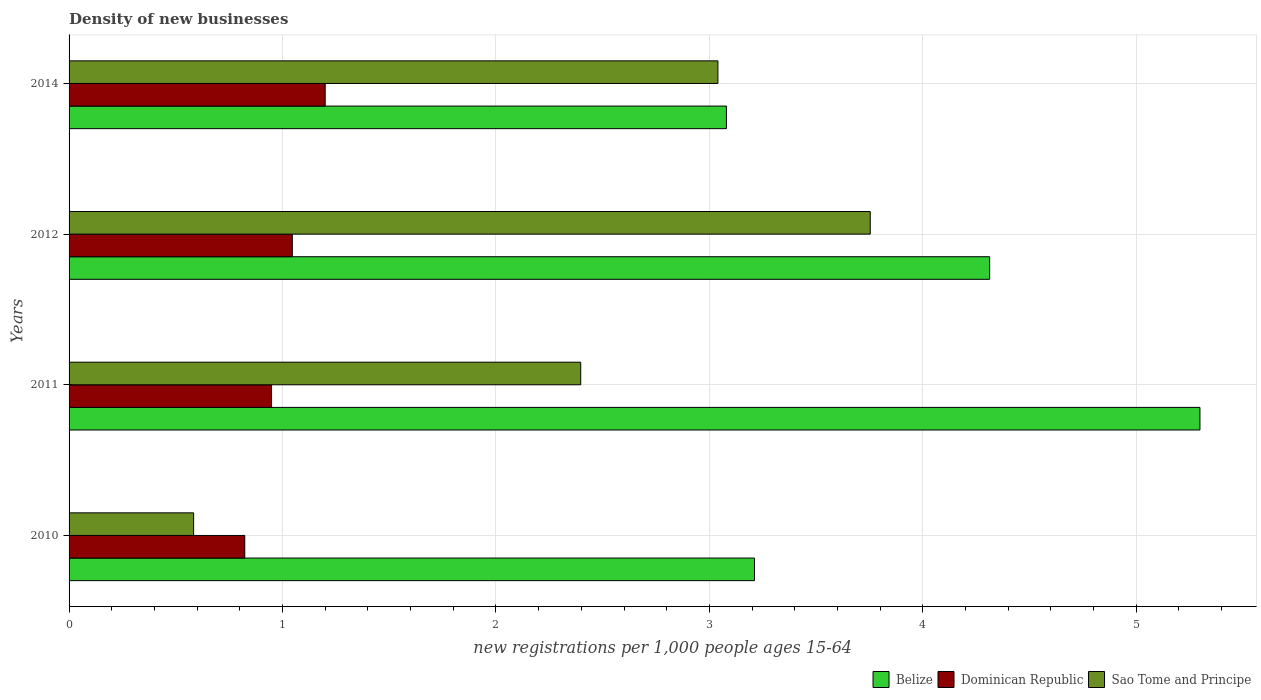Are the number of bars per tick equal to the number of legend labels?
Offer a very short reply. Yes. Are the number of bars on each tick of the Y-axis equal?
Your answer should be compact. Yes. How many bars are there on the 3rd tick from the top?
Offer a very short reply. 3. How many bars are there on the 1st tick from the bottom?
Ensure brevity in your answer.  3. What is the label of the 2nd group of bars from the top?
Ensure brevity in your answer.  2012. What is the number of new registrations in Belize in 2012?
Offer a very short reply. 4.31. Across all years, what is the maximum number of new registrations in Dominican Republic?
Keep it short and to the point. 1.2. Across all years, what is the minimum number of new registrations in Sao Tome and Principe?
Your response must be concise. 0.58. What is the total number of new registrations in Dominican Republic in the graph?
Your response must be concise. 4.02. What is the difference between the number of new registrations in Dominican Republic in 2010 and that in 2011?
Offer a very short reply. -0.13. What is the difference between the number of new registrations in Belize in 2011 and the number of new registrations in Dominican Republic in 2012?
Make the answer very short. 4.25. What is the average number of new registrations in Belize per year?
Provide a short and direct response. 3.98. In the year 2010, what is the difference between the number of new registrations in Sao Tome and Principe and number of new registrations in Dominican Republic?
Ensure brevity in your answer.  -0.24. What is the ratio of the number of new registrations in Belize in 2011 to that in 2014?
Provide a succinct answer. 1.72. What is the difference between the highest and the second highest number of new registrations in Sao Tome and Principe?
Your answer should be very brief. 0.71. What is the difference between the highest and the lowest number of new registrations in Dominican Republic?
Your answer should be very brief. 0.38. In how many years, is the number of new registrations in Sao Tome and Principe greater than the average number of new registrations in Sao Tome and Principe taken over all years?
Offer a very short reply. 2. Is the sum of the number of new registrations in Sao Tome and Principe in 2010 and 2014 greater than the maximum number of new registrations in Dominican Republic across all years?
Your answer should be very brief. Yes. What does the 1st bar from the top in 2012 represents?
Give a very brief answer. Sao Tome and Principe. What does the 3rd bar from the bottom in 2010 represents?
Provide a succinct answer. Sao Tome and Principe. How many bars are there?
Offer a terse response. 12. Are the values on the major ticks of X-axis written in scientific E-notation?
Your answer should be very brief. No. Does the graph contain any zero values?
Offer a very short reply. No. Does the graph contain grids?
Give a very brief answer. Yes. How many legend labels are there?
Provide a succinct answer. 3. How are the legend labels stacked?
Provide a short and direct response. Horizontal. What is the title of the graph?
Make the answer very short. Density of new businesses. What is the label or title of the X-axis?
Give a very brief answer. New registrations per 1,0 people ages 15-64. What is the label or title of the Y-axis?
Make the answer very short. Years. What is the new registrations per 1,000 people ages 15-64 of Belize in 2010?
Your answer should be very brief. 3.21. What is the new registrations per 1,000 people ages 15-64 of Dominican Republic in 2010?
Your answer should be compact. 0.82. What is the new registrations per 1,000 people ages 15-64 in Sao Tome and Principe in 2010?
Ensure brevity in your answer.  0.58. What is the new registrations per 1,000 people ages 15-64 of Belize in 2011?
Provide a succinct answer. 5.3. What is the new registrations per 1,000 people ages 15-64 in Dominican Republic in 2011?
Keep it short and to the point. 0.95. What is the new registrations per 1,000 people ages 15-64 in Sao Tome and Principe in 2011?
Keep it short and to the point. 2.4. What is the new registrations per 1,000 people ages 15-64 of Belize in 2012?
Provide a short and direct response. 4.31. What is the new registrations per 1,000 people ages 15-64 of Dominican Republic in 2012?
Make the answer very short. 1.05. What is the new registrations per 1,000 people ages 15-64 of Sao Tome and Principe in 2012?
Keep it short and to the point. 3.75. What is the new registrations per 1,000 people ages 15-64 of Belize in 2014?
Keep it short and to the point. 3.08. What is the new registrations per 1,000 people ages 15-64 of Sao Tome and Principe in 2014?
Provide a succinct answer. 3.04. Across all years, what is the maximum new registrations per 1,000 people ages 15-64 of Belize?
Keep it short and to the point. 5.3. Across all years, what is the maximum new registrations per 1,000 people ages 15-64 in Dominican Republic?
Provide a short and direct response. 1.2. Across all years, what is the maximum new registrations per 1,000 people ages 15-64 in Sao Tome and Principe?
Your response must be concise. 3.75. Across all years, what is the minimum new registrations per 1,000 people ages 15-64 in Belize?
Your answer should be compact. 3.08. Across all years, what is the minimum new registrations per 1,000 people ages 15-64 of Dominican Republic?
Your answer should be compact. 0.82. Across all years, what is the minimum new registrations per 1,000 people ages 15-64 of Sao Tome and Principe?
Make the answer very short. 0.58. What is the total new registrations per 1,000 people ages 15-64 of Belize in the graph?
Your answer should be compact. 15.9. What is the total new registrations per 1,000 people ages 15-64 of Dominican Republic in the graph?
Give a very brief answer. 4.02. What is the total new registrations per 1,000 people ages 15-64 of Sao Tome and Principe in the graph?
Offer a very short reply. 9.77. What is the difference between the new registrations per 1,000 people ages 15-64 in Belize in 2010 and that in 2011?
Your answer should be very brief. -2.09. What is the difference between the new registrations per 1,000 people ages 15-64 of Dominican Republic in 2010 and that in 2011?
Offer a terse response. -0.13. What is the difference between the new registrations per 1,000 people ages 15-64 in Sao Tome and Principe in 2010 and that in 2011?
Provide a succinct answer. -1.81. What is the difference between the new registrations per 1,000 people ages 15-64 in Belize in 2010 and that in 2012?
Provide a succinct answer. -1.1. What is the difference between the new registrations per 1,000 people ages 15-64 of Dominican Republic in 2010 and that in 2012?
Give a very brief answer. -0.22. What is the difference between the new registrations per 1,000 people ages 15-64 of Sao Tome and Principe in 2010 and that in 2012?
Ensure brevity in your answer.  -3.17. What is the difference between the new registrations per 1,000 people ages 15-64 of Belize in 2010 and that in 2014?
Offer a very short reply. 0.13. What is the difference between the new registrations per 1,000 people ages 15-64 of Dominican Republic in 2010 and that in 2014?
Keep it short and to the point. -0.38. What is the difference between the new registrations per 1,000 people ages 15-64 in Sao Tome and Principe in 2010 and that in 2014?
Your response must be concise. -2.46. What is the difference between the new registrations per 1,000 people ages 15-64 of Dominican Republic in 2011 and that in 2012?
Your response must be concise. -0.1. What is the difference between the new registrations per 1,000 people ages 15-64 of Sao Tome and Principe in 2011 and that in 2012?
Offer a terse response. -1.36. What is the difference between the new registrations per 1,000 people ages 15-64 of Belize in 2011 and that in 2014?
Offer a terse response. 2.22. What is the difference between the new registrations per 1,000 people ages 15-64 of Dominican Republic in 2011 and that in 2014?
Give a very brief answer. -0.25. What is the difference between the new registrations per 1,000 people ages 15-64 in Sao Tome and Principe in 2011 and that in 2014?
Provide a short and direct response. -0.64. What is the difference between the new registrations per 1,000 people ages 15-64 in Belize in 2012 and that in 2014?
Offer a very short reply. 1.23. What is the difference between the new registrations per 1,000 people ages 15-64 in Dominican Republic in 2012 and that in 2014?
Provide a succinct answer. -0.15. What is the difference between the new registrations per 1,000 people ages 15-64 in Sao Tome and Principe in 2012 and that in 2014?
Offer a very short reply. 0.71. What is the difference between the new registrations per 1,000 people ages 15-64 in Belize in 2010 and the new registrations per 1,000 people ages 15-64 in Dominican Republic in 2011?
Provide a short and direct response. 2.26. What is the difference between the new registrations per 1,000 people ages 15-64 of Belize in 2010 and the new registrations per 1,000 people ages 15-64 of Sao Tome and Principe in 2011?
Provide a short and direct response. 0.81. What is the difference between the new registrations per 1,000 people ages 15-64 in Dominican Republic in 2010 and the new registrations per 1,000 people ages 15-64 in Sao Tome and Principe in 2011?
Offer a terse response. -1.57. What is the difference between the new registrations per 1,000 people ages 15-64 of Belize in 2010 and the new registrations per 1,000 people ages 15-64 of Dominican Republic in 2012?
Your answer should be very brief. 2.17. What is the difference between the new registrations per 1,000 people ages 15-64 in Belize in 2010 and the new registrations per 1,000 people ages 15-64 in Sao Tome and Principe in 2012?
Your answer should be compact. -0.54. What is the difference between the new registrations per 1,000 people ages 15-64 of Dominican Republic in 2010 and the new registrations per 1,000 people ages 15-64 of Sao Tome and Principe in 2012?
Make the answer very short. -2.93. What is the difference between the new registrations per 1,000 people ages 15-64 in Belize in 2010 and the new registrations per 1,000 people ages 15-64 in Dominican Republic in 2014?
Your answer should be compact. 2.01. What is the difference between the new registrations per 1,000 people ages 15-64 in Belize in 2010 and the new registrations per 1,000 people ages 15-64 in Sao Tome and Principe in 2014?
Your answer should be very brief. 0.17. What is the difference between the new registrations per 1,000 people ages 15-64 of Dominican Republic in 2010 and the new registrations per 1,000 people ages 15-64 of Sao Tome and Principe in 2014?
Provide a succinct answer. -2.22. What is the difference between the new registrations per 1,000 people ages 15-64 of Belize in 2011 and the new registrations per 1,000 people ages 15-64 of Dominican Republic in 2012?
Offer a very short reply. 4.25. What is the difference between the new registrations per 1,000 people ages 15-64 in Belize in 2011 and the new registrations per 1,000 people ages 15-64 in Sao Tome and Principe in 2012?
Your answer should be very brief. 1.54. What is the difference between the new registrations per 1,000 people ages 15-64 in Dominican Republic in 2011 and the new registrations per 1,000 people ages 15-64 in Sao Tome and Principe in 2012?
Provide a short and direct response. -2.81. What is the difference between the new registrations per 1,000 people ages 15-64 of Belize in 2011 and the new registrations per 1,000 people ages 15-64 of Dominican Republic in 2014?
Your answer should be very brief. 4.1. What is the difference between the new registrations per 1,000 people ages 15-64 in Belize in 2011 and the new registrations per 1,000 people ages 15-64 in Sao Tome and Principe in 2014?
Make the answer very short. 2.26. What is the difference between the new registrations per 1,000 people ages 15-64 of Dominican Republic in 2011 and the new registrations per 1,000 people ages 15-64 of Sao Tome and Principe in 2014?
Keep it short and to the point. -2.09. What is the difference between the new registrations per 1,000 people ages 15-64 in Belize in 2012 and the new registrations per 1,000 people ages 15-64 in Dominican Republic in 2014?
Your answer should be very brief. 3.11. What is the difference between the new registrations per 1,000 people ages 15-64 of Belize in 2012 and the new registrations per 1,000 people ages 15-64 of Sao Tome and Principe in 2014?
Ensure brevity in your answer.  1.27. What is the difference between the new registrations per 1,000 people ages 15-64 in Dominican Republic in 2012 and the new registrations per 1,000 people ages 15-64 in Sao Tome and Principe in 2014?
Your answer should be very brief. -1.99. What is the average new registrations per 1,000 people ages 15-64 in Belize per year?
Your answer should be compact. 3.98. What is the average new registrations per 1,000 people ages 15-64 of Dominican Republic per year?
Your answer should be compact. 1. What is the average new registrations per 1,000 people ages 15-64 of Sao Tome and Principe per year?
Your answer should be compact. 2.44. In the year 2010, what is the difference between the new registrations per 1,000 people ages 15-64 in Belize and new registrations per 1,000 people ages 15-64 in Dominican Republic?
Provide a short and direct response. 2.39. In the year 2010, what is the difference between the new registrations per 1,000 people ages 15-64 in Belize and new registrations per 1,000 people ages 15-64 in Sao Tome and Principe?
Offer a very short reply. 2.63. In the year 2010, what is the difference between the new registrations per 1,000 people ages 15-64 in Dominican Republic and new registrations per 1,000 people ages 15-64 in Sao Tome and Principe?
Ensure brevity in your answer.  0.24. In the year 2011, what is the difference between the new registrations per 1,000 people ages 15-64 of Belize and new registrations per 1,000 people ages 15-64 of Dominican Republic?
Provide a short and direct response. 4.35. In the year 2011, what is the difference between the new registrations per 1,000 people ages 15-64 in Belize and new registrations per 1,000 people ages 15-64 in Sao Tome and Principe?
Offer a very short reply. 2.9. In the year 2011, what is the difference between the new registrations per 1,000 people ages 15-64 in Dominican Republic and new registrations per 1,000 people ages 15-64 in Sao Tome and Principe?
Ensure brevity in your answer.  -1.45. In the year 2012, what is the difference between the new registrations per 1,000 people ages 15-64 of Belize and new registrations per 1,000 people ages 15-64 of Dominican Republic?
Offer a very short reply. 3.27. In the year 2012, what is the difference between the new registrations per 1,000 people ages 15-64 in Belize and new registrations per 1,000 people ages 15-64 in Sao Tome and Principe?
Keep it short and to the point. 0.56. In the year 2012, what is the difference between the new registrations per 1,000 people ages 15-64 in Dominican Republic and new registrations per 1,000 people ages 15-64 in Sao Tome and Principe?
Give a very brief answer. -2.71. In the year 2014, what is the difference between the new registrations per 1,000 people ages 15-64 in Belize and new registrations per 1,000 people ages 15-64 in Dominican Republic?
Keep it short and to the point. 1.88. In the year 2014, what is the difference between the new registrations per 1,000 people ages 15-64 of Dominican Republic and new registrations per 1,000 people ages 15-64 of Sao Tome and Principe?
Your answer should be very brief. -1.84. What is the ratio of the new registrations per 1,000 people ages 15-64 in Belize in 2010 to that in 2011?
Make the answer very short. 0.61. What is the ratio of the new registrations per 1,000 people ages 15-64 of Dominican Republic in 2010 to that in 2011?
Offer a terse response. 0.87. What is the ratio of the new registrations per 1,000 people ages 15-64 in Sao Tome and Principe in 2010 to that in 2011?
Your answer should be very brief. 0.24. What is the ratio of the new registrations per 1,000 people ages 15-64 of Belize in 2010 to that in 2012?
Your response must be concise. 0.74. What is the ratio of the new registrations per 1,000 people ages 15-64 in Dominican Republic in 2010 to that in 2012?
Your answer should be very brief. 0.79. What is the ratio of the new registrations per 1,000 people ages 15-64 in Sao Tome and Principe in 2010 to that in 2012?
Offer a terse response. 0.16. What is the ratio of the new registrations per 1,000 people ages 15-64 in Belize in 2010 to that in 2014?
Ensure brevity in your answer.  1.04. What is the ratio of the new registrations per 1,000 people ages 15-64 in Dominican Republic in 2010 to that in 2014?
Offer a terse response. 0.69. What is the ratio of the new registrations per 1,000 people ages 15-64 of Sao Tome and Principe in 2010 to that in 2014?
Your answer should be very brief. 0.19. What is the ratio of the new registrations per 1,000 people ages 15-64 of Belize in 2011 to that in 2012?
Offer a terse response. 1.23. What is the ratio of the new registrations per 1,000 people ages 15-64 of Dominican Republic in 2011 to that in 2012?
Ensure brevity in your answer.  0.91. What is the ratio of the new registrations per 1,000 people ages 15-64 of Sao Tome and Principe in 2011 to that in 2012?
Your answer should be very brief. 0.64. What is the ratio of the new registrations per 1,000 people ages 15-64 in Belize in 2011 to that in 2014?
Provide a short and direct response. 1.72. What is the ratio of the new registrations per 1,000 people ages 15-64 in Dominican Republic in 2011 to that in 2014?
Give a very brief answer. 0.79. What is the ratio of the new registrations per 1,000 people ages 15-64 of Sao Tome and Principe in 2011 to that in 2014?
Your response must be concise. 0.79. What is the ratio of the new registrations per 1,000 people ages 15-64 of Belize in 2012 to that in 2014?
Your response must be concise. 1.4. What is the ratio of the new registrations per 1,000 people ages 15-64 in Dominican Republic in 2012 to that in 2014?
Offer a very short reply. 0.87. What is the ratio of the new registrations per 1,000 people ages 15-64 of Sao Tome and Principe in 2012 to that in 2014?
Offer a terse response. 1.23. What is the difference between the highest and the second highest new registrations per 1,000 people ages 15-64 in Dominican Republic?
Your answer should be very brief. 0.15. What is the difference between the highest and the second highest new registrations per 1,000 people ages 15-64 of Sao Tome and Principe?
Provide a short and direct response. 0.71. What is the difference between the highest and the lowest new registrations per 1,000 people ages 15-64 of Belize?
Provide a succinct answer. 2.22. What is the difference between the highest and the lowest new registrations per 1,000 people ages 15-64 in Dominican Republic?
Your answer should be very brief. 0.38. What is the difference between the highest and the lowest new registrations per 1,000 people ages 15-64 of Sao Tome and Principe?
Provide a short and direct response. 3.17. 